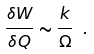<formula> <loc_0><loc_0><loc_500><loc_500>\frac { \delta W } { \delta Q } \sim \frac { k } { \Omega } \ .</formula> 